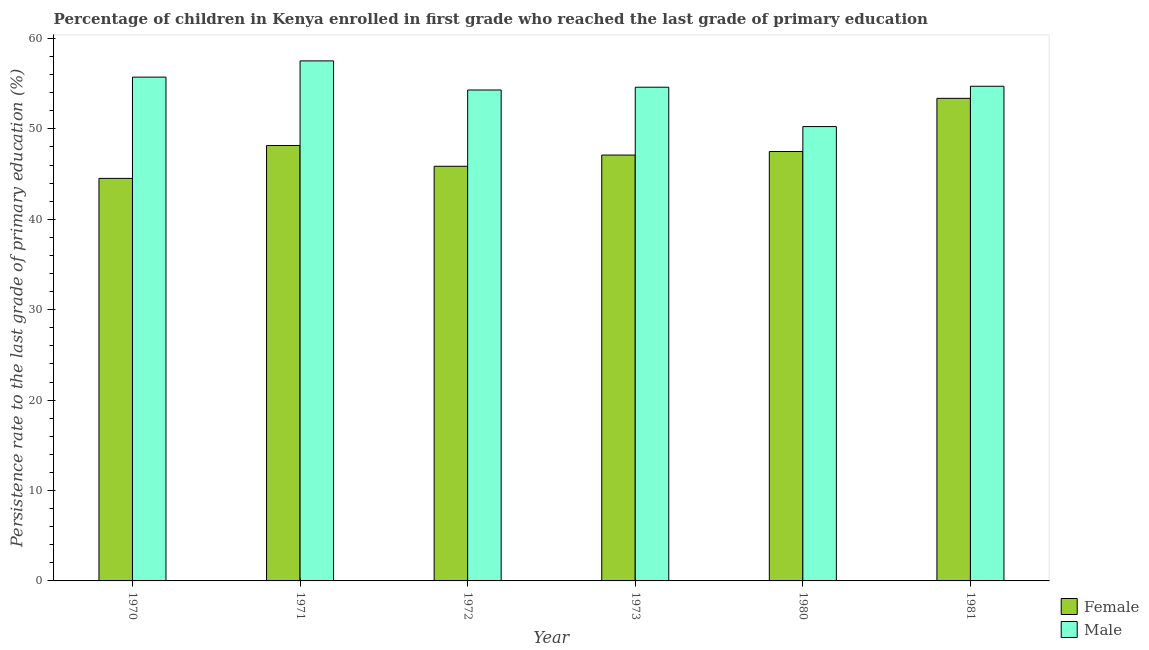How many groups of bars are there?
Ensure brevity in your answer.  6. How many bars are there on the 3rd tick from the left?
Offer a terse response. 2. What is the persistence rate of male students in 1980?
Your answer should be compact. 50.25. Across all years, what is the maximum persistence rate of male students?
Offer a terse response. 57.52. Across all years, what is the minimum persistence rate of male students?
Your answer should be compact. 50.25. In which year was the persistence rate of female students maximum?
Offer a terse response. 1981. In which year was the persistence rate of male students minimum?
Offer a very short reply. 1980. What is the total persistence rate of male students in the graph?
Make the answer very short. 327.11. What is the difference between the persistence rate of female students in 1971 and that in 1972?
Your answer should be compact. 2.3. What is the difference between the persistence rate of male students in 1973 and the persistence rate of female students in 1981?
Give a very brief answer. -0.11. What is the average persistence rate of female students per year?
Make the answer very short. 47.75. What is the ratio of the persistence rate of female students in 1972 to that in 1980?
Offer a very short reply. 0.97. Is the persistence rate of female students in 1970 less than that in 1980?
Offer a terse response. Yes. Is the difference between the persistence rate of male students in 1971 and 1972 greater than the difference between the persistence rate of female students in 1971 and 1972?
Your answer should be compact. No. What is the difference between the highest and the second highest persistence rate of female students?
Your answer should be very brief. 5.22. What is the difference between the highest and the lowest persistence rate of female students?
Ensure brevity in your answer.  8.85. Is the sum of the persistence rate of female students in 1973 and 1981 greater than the maximum persistence rate of male students across all years?
Keep it short and to the point. Yes. What does the 1st bar from the right in 1971 represents?
Your answer should be very brief. Male. How many years are there in the graph?
Offer a terse response. 6. What is the difference between two consecutive major ticks on the Y-axis?
Provide a short and direct response. 10. Does the graph contain any zero values?
Your response must be concise. No. Does the graph contain grids?
Your response must be concise. No. Where does the legend appear in the graph?
Offer a very short reply. Bottom right. How many legend labels are there?
Your answer should be compact. 2. How are the legend labels stacked?
Your response must be concise. Vertical. What is the title of the graph?
Make the answer very short. Percentage of children in Kenya enrolled in first grade who reached the last grade of primary education. Does "Register a business" appear as one of the legend labels in the graph?
Give a very brief answer. No. What is the label or title of the Y-axis?
Give a very brief answer. Persistence rate to the last grade of primary education (%). What is the Persistence rate to the last grade of primary education (%) of Female in 1970?
Give a very brief answer. 44.52. What is the Persistence rate to the last grade of primary education (%) in Male in 1970?
Ensure brevity in your answer.  55.72. What is the Persistence rate to the last grade of primary education (%) of Female in 1971?
Your answer should be compact. 48.16. What is the Persistence rate to the last grade of primary education (%) of Male in 1971?
Make the answer very short. 57.52. What is the Persistence rate to the last grade of primary education (%) of Female in 1972?
Keep it short and to the point. 45.86. What is the Persistence rate to the last grade of primary education (%) in Male in 1972?
Your answer should be very brief. 54.3. What is the Persistence rate to the last grade of primary education (%) of Female in 1973?
Your response must be concise. 47.1. What is the Persistence rate to the last grade of primary education (%) in Male in 1973?
Ensure brevity in your answer.  54.61. What is the Persistence rate to the last grade of primary education (%) in Female in 1980?
Make the answer very short. 47.49. What is the Persistence rate to the last grade of primary education (%) in Male in 1980?
Offer a very short reply. 50.25. What is the Persistence rate to the last grade of primary education (%) in Female in 1981?
Your answer should be compact. 53.38. What is the Persistence rate to the last grade of primary education (%) in Male in 1981?
Keep it short and to the point. 54.71. Across all years, what is the maximum Persistence rate to the last grade of primary education (%) in Female?
Your response must be concise. 53.38. Across all years, what is the maximum Persistence rate to the last grade of primary education (%) in Male?
Keep it short and to the point. 57.52. Across all years, what is the minimum Persistence rate to the last grade of primary education (%) of Female?
Make the answer very short. 44.52. Across all years, what is the minimum Persistence rate to the last grade of primary education (%) of Male?
Your answer should be compact. 50.25. What is the total Persistence rate to the last grade of primary education (%) in Female in the graph?
Provide a succinct answer. 286.52. What is the total Persistence rate to the last grade of primary education (%) of Male in the graph?
Give a very brief answer. 327.11. What is the difference between the Persistence rate to the last grade of primary education (%) of Female in 1970 and that in 1971?
Offer a very short reply. -3.64. What is the difference between the Persistence rate to the last grade of primary education (%) of Male in 1970 and that in 1971?
Your answer should be compact. -1.8. What is the difference between the Persistence rate to the last grade of primary education (%) of Female in 1970 and that in 1972?
Provide a succinct answer. -1.34. What is the difference between the Persistence rate to the last grade of primary education (%) of Male in 1970 and that in 1972?
Offer a terse response. 1.42. What is the difference between the Persistence rate to the last grade of primary education (%) in Female in 1970 and that in 1973?
Your answer should be compact. -2.58. What is the difference between the Persistence rate to the last grade of primary education (%) of Male in 1970 and that in 1973?
Your answer should be very brief. 1.12. What is the difference between the Persistence rate to the last grade of primary education (%) in Female in 1970 and that in 1980?
Provide a succinct answer. -2.97. What is the difference between the Persistence rate to the last grade of primary education (%) in Male in 1970 and that in 1980?
Offer a terse response. 5.47. What is the difference between the Persistence rate to the last grade of primary education (%) in Female in 1970 and that in 1981?
Your answer should be compact. -8.85. What is the difference between the Persistence rate to the last grade of primary education (%) of Male in 1970 and that in 1981?
Your response must be concise. 1.01. What is the difference between the Persistence rate to the last grade of primary education (%) of Female in 1971 and that in 1972?
Make the answer very short. 2.3. What is the difference between the Persistence rate to the last grade of primary education (%) in Male in 1971 and that in 1972?
Provide a short and direct response. 3.22. What is the difference between the Persistence rate to the last grade of primary education (%) in Female in 1971 and that in 1973?
Ensure brevity in your answer.  1.06. What is the difference between the Persistence rate to the last grade of primary education (%) of Male in 1971 and that in 1973?
Your answer should be very brief. 2.91. What is the difference between the Persistence rate to the last grade of primary education (%) of Female in 1971 and that in 1980?
Your answer should be very brief. 0.66. What is the difference between the Persistence rate to the last grade of primary education (%) of Male in 1971 and that in 1980?
Your answer should be very brief. 7.27. What is the difference between the Persistence rate to the last grade of primary education (%) in Female in 1971 and that in 1981?
Your response must be concise. -5.22. What is the difference between the Persistence rate to the last grade of primary education (%) in Male in 1971 and that in 1981?
Make the answer very short. 2.81. What is the difference between the Persistence rate to the last grade of primary education (%) of Female in 1972 and that in 1973?
Provide a succinct answer. -1.24. What is the difference between the Persistence rate to the last grade of primary education (%) in Male in 1972 and that in 1973?
Keep it short and to the point. -0.31. What is the difference between the Persistence rate to the last grade of primary education (%) in Female in 1972 and that in 1980?
Offer a very short reply. -1.63. What is the difference between the Persistence rate to the last grade of primary education (%) in Male in 1972 and that in 1980?
Offer a terse response. 4.04. What is the difference between the Persistence rate to the last grade of primary education (%) in Female in 1972 and that in 1981?
Your answer should be very brief. -7.51. What is the difference between the Persistence rate to the last grade of primary education (%) of Male in 1972 and that in 1981?
Offer a terse response. -0.41. What is the difference between the Persistence rate to the last grade of primary education (%) of Female in 1973 and that in 1980?
Make the answer very short. -0.39. What is the difference between the Persistence rate to the last grade of primary education (%) in Male in 1973 and that in 1980?
Provide a succinct answer. 4.35. What is the difference between the Persistence rate to the last grade of primary education (%) in Female in 1973 and that in 1981?
Provide a succinct answer. -6.27. What is the difference between the Persistence rate to the last grade of primary education (%) in Male in 1973 and that in 1981?
Ensure brevity in your answer.  -0.11. What is the difference between the Persistence rate to the last grade of primary education (%) of Female in 1980 and that in 1981?
Provide a short and direct response. -5.88. What is the difference between the Persistence rate to the last grade of primary education (%) of Male in 1980 and that in 1981?
Give a very brief answer. -4.46. What is the difference between the Persistence rate to the last grade of primary education (%) of Female in 1970 and the Persistence rate to the last grade of primary education (%) of Male in 1971?
Offer a terse response. -13. What is the difference between the Persistence rate to the last grade of primary education (%) in Female in 1970 and the Persistence rate to the last grade of primary education (%) in Male in 1972?
Make the answer very short. -9.78. What is the difference between the Persistence rate to the last grade of primary education (%) of Female in 1970 and the Persistence rate to the last grade of primary education (%) of Male in 1973?
Make the answer very short. -10.08. What is the difference between the Persistence rate to the last grade of primary education (%) of Female in 1970 and the Persistence rate to the last grade of primary education (%) of Male in 1980?
Provide a short and direct response. -5.73. What is the difference between the Persistence rate to the last grade of primary education (%) of Female in 1970 and the Persistence rate to the last grade of primary education (%) of Male in 1981?
Make the answer very short. -10.19. What is the difference between the Persistence rate to the last grade of primary education (%) in Female in 1971 and the Persistence rate to the last grade of primary education (%) in Male in 1972?
Your answer should be very brief. -6.14. What is the difference between the Persistence rate to the last grade of primary education (%) in Female in 1971 and the Persistence rate to the last grade of primary education (%) in Male in 1973?
Your answer should be very brief. -6.45. What is the difference between the Persistence rate to the last grade of primary education (%) of Female in 1971 and the Persistence rate to the last grade of primary education (%) of Male in 1980?
Provide a short and direct response. -2.09. What is the difference between the Persistence rate to the last grade of primary education (%) in Female in 1971 and the Persistence rate to the last grade of primary education (%) in Male in 1981?
Offer a very short reply. -6.55. What is the difference between the Persistence rate to the last grade of primary education (%) in Female in 1972 and the Persistence rate to the last grade of primary education (%) in Male in 1973?
Ensure brevity in your answer.  -8.74. What is the difference between the Persistence rate to the last grade of primary education (%) in Female in 1972 and the Persistence rate to the last grade of primary education (%) in Male in 1980?
Your answer should be very brief. -4.39. What is the difference between the Persistence rate to the last grade of primary education (%) of Female in 1972 and the Persistence rate to the last grade of primary education (%) of Male in 1981?
Keep it short and to the point. -8.85. What is the difference between the Persistence rate to the last grade of primary education (%) of Female in 1973 and the Persistence rate to the last grade of primary education (%) of Male in 1980?
Make the answer very short. -3.15. What is the difference between the Persistence rate to the last grade of primary education (%) in Female in 1973 and the Persistence rate to the last grade of primary education (%) in Male in 1981?
Provide a short and direct response. -7.61. What is the difference between the Persistence rate to the last grade of primary education (%) of Female in 1980 and the Persistence rate to the last grade of primary education (%) of Male in 1981?
Your answer should be compact. -7.22. What is the average Persistence rate to the last grade of primary education (%) in Female per year?
Provide a short and direct response. 47.75. What is the average Persistence rate to the last grade of primary education (%) of Male per year?
Offer a very short reply. 54.52. In the year 1970, what is the difference between the Persistence rate to the last grade of primary education (%) of Female and Persistence rate to the last grade of primary education (%) of Male?
Offer a terse response. -11.2. In the year 1971, what is the difference between the Persistence rate to the last grade of primary education (%) of Female and Persistence rate to the last grade of primary education (%) of Male?
Your answer should be very brief. -9.36. In the year 1972, what is the difference between the Persistence rate to the last grade of primary education (%) of Female and Persistence rate to the last grade of primary education (%) of Male?
Your answer should be very brief. -8.44. In the year 1973, what is the difference between the Persistence rate to the last grade of primary education (%) in Female and Persistence rate to the last grade of primary education (%) in Male?
Make the answer very short. -7.5. In the year 1980, what is the difference between the Persistence rate to the last grade of primary education (%) in Female and Persistence rate to the last grade of primary education (%) in Male?
Your answer should be very brief. -2.76. In the year 1981, what is the difference between the Persistence rate to the last grade of primary education (%) of Female and Persistence rate to the last grade of primary education (%) of Male?
Offer a very short reply. -1.34. What is the ratio of the Persistence rate to the last grade of primary education (%) in Female in 1970 to that in 1971?
Keep it short and to the point. 0.92. What is the ratio of the Persistence rate to the last grade of primary education (%) in Male in 1970 to that in 1971?
Your answer should be very brief. 0.97. What is the ratio of the Persistence rate to the last grade of primary education (%) of Female in 1970 to that in 1972?
Ensure brevity in your answer.  0.97. What is the ratio of the Persistence rate to the last grade of primary education (%) of Male in 1970 to that in 1972?
Provide a short and direct response. 1.03. What is the ratio of the Persistence rate to the last grade of primary education (%) in Female in 1970 to that in 1973?
Provide a succinct answer. 0.95. What is the ratio of the Persistence rate to the last grade of primary education (%) of Male in 1970 to that in 1973?
Your answer should be compact. 1.02. What is the ratio of the Persistence rate to the last grade of primary education (%) of Female in 1970 to that in 1980?
Ensure brevity in your answer.  0.94. What is the ratio of the Persistence rate to the last grade of primary education (%) in Male in 1970 to that in 1980?
Offer a terse response. 1.11. What is the ratio of the Persistence rate to the last grade of primary education (%) in Female in 1970 to that in 1981?
Provide a succinct answer. 0.83. What is the ratio of the Persistence rate to the last grade of primary education (%) in Male in 1970 to that in 1981?
Offer a very short reply. 1.02. What is the ratio of the Persistence rate to the last grade of primary education (%) of Female in 1971 to that in 1972?
Ensure brevity in your answer.  1.05. What is the ratio of the Persistence rate to the last grade of primary education (%) of Male in 1971 to that in 1972?
Offer a very short reply. 1.06. What is the ratio of the Persistence rate to the last grade of primary education (%) in Female in 1971 to that in 1973?
Your answer should be very brief. 1.02. What is the ratio of the Persistence rate to the last grade of primary education (%) in Male in 1971 to that in 1973?
Ensure brevity in your answer.  1.05. What is the ratio of the Persistence rate to the last grade of primary education (%) in Male in 1971 to that in 1980?
Provide a succinct answer. 1.14. What is the ratio of the Persistence rate to the last grade of primary education (%) in Female in 1971 to that in 1981?
Make the answer very short. 0.9. What is the ratio of the Persistence rate to the last grade of primary education (%) in Male in 1971 to that in 1981?
Give a very brief answer. 1.05. What is the ratio of the Persistence rate to the last grade of primary education (%) of Female in 1972 to that in 1973?
Ensure brevity in your answer.  0.97. What is the ratio of the Persistence rate to the last grade of primary education (%) of Male in 1972 to that in 1973?
Offer a terse response. 0.99. What is the ratio of the Persistence rate to the last grade of primary education (%) in Female in 1972 to that in 1980?
Your response must be concise. 0.97. What is the ratio of the Persistence rate to the last grade of primary education (%) in Male in 1972 to that in 1980?
Your answer should be compact. 1.08. What is the ratio of the Persistence rate to the last grade of primary education (%) in Female in 1972 to that in 1981?
Your response must be concise. 0.86. What is the ratio of the Persistence rate to the last grade of primary education (%) of Female in 1973 to that in 1980?
Ensure brevity in your answer.  0.99. What is the ratio of the Persistence rate to the last grade of primary education (%) of Male in 1973 to that in 1980?
Keep it short and to the point. 1.09. What is the ratio of the Persistence rate to the last grade of primary education (%) of Female in 1973 to that in 1981?
Provide a short and direct response. 0.88. What is the ratio of the Persistence rate to the last grade of primary education (%) in Male in 1973 to that in 1981?
Provide a short and direct response. 1. What is the ratio of the Persistence rate to the last grade of primary education (%) in Female in 1980 to that in 1981?
Provide a short and direct response. 0.89. What is the ratio of the Persistence rate to the last grade of primary education (%) in Male in 1980 to that in 1981?
Keep it short and to the point. 0.92. What is the difference between the highest and the second highest Persistence rate to the last grade of primary education (%) of Female?
Your answer should be very brief. 5.22. What is the difference between the highest and the second highest Persistence rate to the last grade of primary education (%) in Male?
Offer a terse response. 1.8. What is the difference between the highest and the lowest Persistence rate to the last grade of primary education (%) of Female?
Ensure brevity in your answer.  8.85. What is the difference between the highest and the lowest Persistence rate to the last grade of primary education (%) of Male?
Make the answer very short. 7.27. 